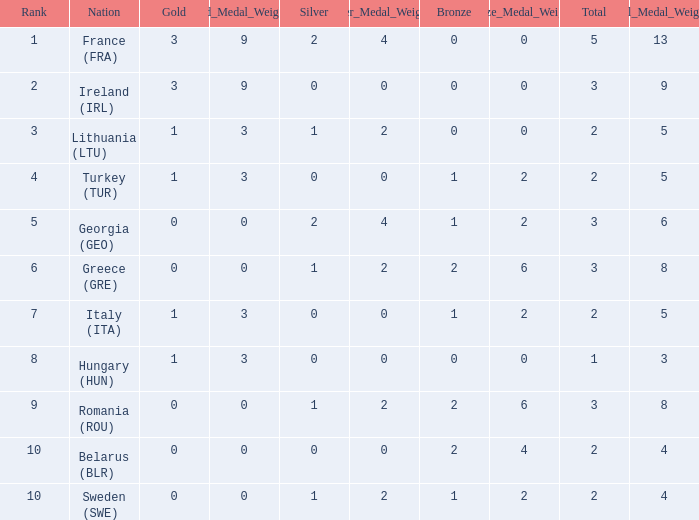What are the most bronze medals in a rank more than 1 with a total larger than 3? None. 